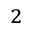<formula> <loc_0><loc_0><loc_500><loc_500>_ { 2 }</formula> 